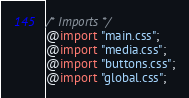Convert code to text. <code><loc_0><loc_0><loc_500><loc_500><_CSS_>/* Imports */
@import "main.css";
@import "media.css";
@import "buttons.css";
@import "global.css";</code> 